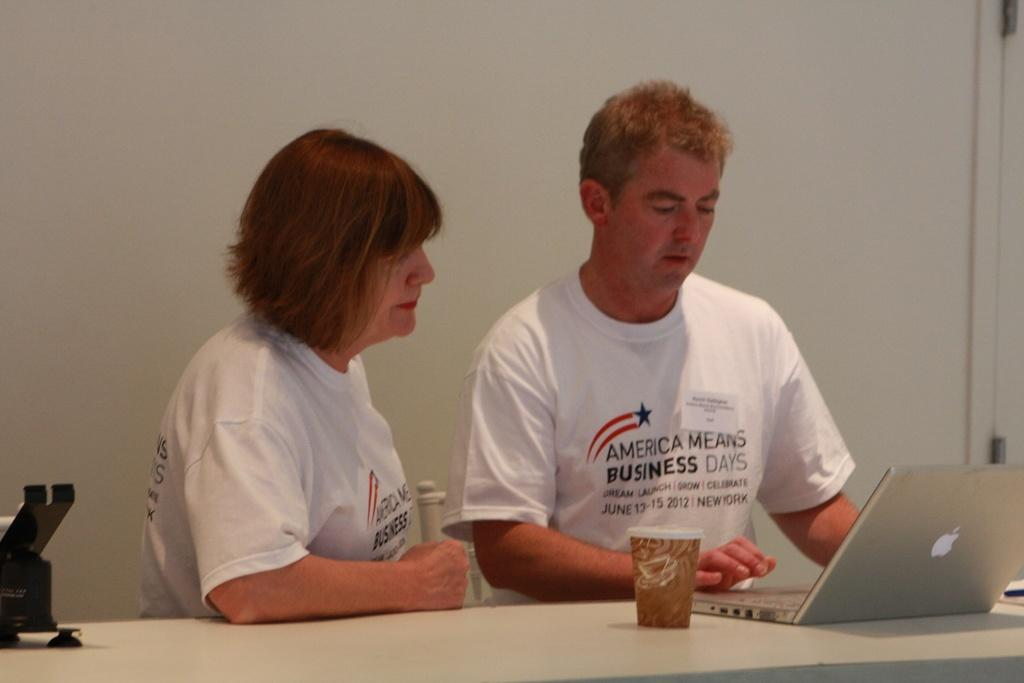How many people are in the image? There are two persons in the image. What are the two persons doing in the image? The two persons are sitting in front of a table. What objects can be seen on the table? There is a laptop and a glass on the table. What color are the t-shirts worn by the two persons? Both persons are wearing white color t-shirts. Can you see any snails crawling on the grass in the image? There is no grass or snails present in the image. What type of good-bye gesture is being exchanged between the two persons in the image? There is no good-bye gesture being exchanged between the two persons in the image; they are simply sitting in front of a table. 